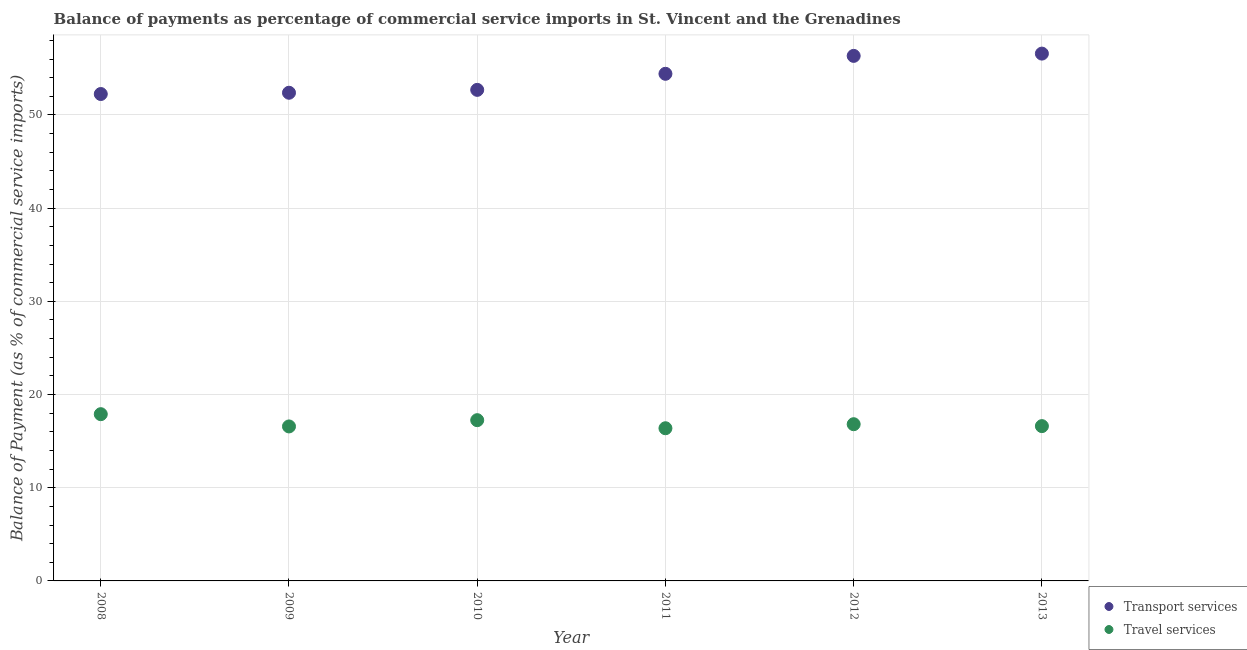Is the number of dotlines equal to the number of legend labels?
Your answer should be very brief. Yes. What is the balance of payments of transport services in 2008?
Offer a very short reply. 52.24. Across all years, what is the maximum balance of payments of travel services?
Your response must be concise. 17.89. Across all years, what is the minimum balance of payments of transport services?
Your answer should be very brief. 52.24. In which year was the balance of payments of transport services minimum?
Ensure brevity in your answer.  2008. What is the total balance of payments of transport services in the graph?
Your answer should be very brief. 324.64. What is the difference between the balance of payments of transport services in 2008 and that in 2009?
Provide a succinct answer. -0.14. What is the difference between the balance of payments of transport services in 2011 and the balance of payments of travel services in 2013?
Make the answer very short. 37.8. What is the average balance of payments of transport services per year?
Provide a short and direct response. 54.11. In the year 2011, what is the difference between the balance of payments of transport services and balance of payments of travel services?
Ensure brevity in your answer.  38.03. What is the ratio of the balance of payments of travel services in 2010 to that in 2012?
Offer a terse response. 1.03. What is the difference between the highest and the second highest balance of payments of travel services?
Your response must be concise. 0.64. What is the difference between the highest and the lowest balance of payments of travel services?
Your response must be concise. 1.51. Does the balance of payments of transport services monotonically increase over the years?
Make the answer very short. Yes. Is the balance of payments of transport services strictly greater than the balance of payments of travel services over the years?
Ensure brevity in your answer.  Yes. How many years are there in the graph?
Provide a succinct answer. 6. Are the values on the major ticks of Y-axis written in scientific E-notation?
Provide a succinct answer. No. How many legend labels are there?
Your answer should be very brief. 2. What is the title of the graph?
Your answer should be very brief. Balance of payments as percentage of commercial service imports in St. Vincent and the Grenadines. What is the label or title of the X-axis?
Keep it short and to the point. Year. What is the label or title of the Y-axis?
Offer a very short reply. Balance of Payment (as % of commercial service imports). What is the Balance of Payment (as % of commercial service imports) of Transport services in 2008?
Your response must be concise. 52.24. What is the Balance of Payment (as % of commercial service imports) in Travel services in 2008?
Ensure brevity in your answer.  17.89. What is the Balance of Payment (as % of commercial service imports) of Transport services in 2009?
Offer a terse response. 52.38. What is the Balance of Payment (as % of commercial service imports) in Travel services in 2009?
Your response must be concise. 16.58. What is the Balance of Payment (as % of commercial service imports) of Transport services in 2010?
Ensure brevity in your answer.  52.69. What is the Balance of Payment (as % of commercial service imports) in Travel services in 2010?
Keep it short and to the point. 17.25. What is the Balance of Payment (as % of commercial service imports) in Transport services in 2011?
Your answer should be very brief. 54.41. What is the Balance of Payment (as % of commercial service imports) in Travel services in 2011?
Make the answer very short. 16.38. What is the Balance of Payment (as % of commercial service imports) in Transport services in 2012?
Ensure brevity in your answer.  56.34. What is the Balance of Payment (as % of commercial service imports) of Travel services in 2012?
Offer a very short reply. 16.82. What is the Balance of Payment (as % of commercial service imports) of Transport services in 2013?
Offer a very short reply. 56.58. What is the Balance of Payment (as % of commercial service imports) in Travel services in 2013?
Provide a short and direct response. 16.61. Across all years, what is the maximum Balance of Payment (as % of commercial service imports) of Transport services?
Keep it short and to the point. 56.58. Across all years, what is the maximum Balance of Payment (as % of commercial service imports) of Travel services?
Make the answer very short. 17.89. Across all years, what is the minimum Balance of Payment (as % of commercial service imports) in Transport services?
Your answer should be compact. 52.24. Across all years, what is the minimum Balance of Payment (as % of commercial service imports) of Travel services?
Make the answer very short. 16.38. What is the total Balance of Payment (as % of commercial service imports) of Transport services in the graph?
Ensure brevity in your answer.  324.64. What is the total Balance of Payment (as % of commercial service imports) of Travel services in the graph?
Keep it short and to the point. 101.52. What is the difference between the Balance of Payment (as % of commercial service imports) in Transport services in 2008 and that in 2009?
Give a very brief answer. -0.14. What is the difference between the Balance of Payment (as % of commercial service imports) in Travel services in 2008 and that in 2009?
Keep it short and to the point. 1.32. What is the difference between the Balance of Payment (as % of commercial service imports) in Transport services in 2008 and that in 2010?
Offer a terse response. -0.45. What is the difference between the Balance of Payment (as % of commercial service imports) in Travel services in 2008 and that in 2010?
Your answer should be very brief. 0.64. What is the difference between the Balance of Payment (as % of commercial service imports) in Transport services in 2008 and that in 2011?
Your response must be concise. -2.17. What is the difference between the Balance of Payment (as % of commercial service imports) in Travel services in 2008 and that in 2011?
Give a very brief answer. 1.51. What is the difference between the Balance of Payment (as % of commercial service imports) in Transport services in 2008 and that in 2012?
Provide a short and direct response. -4.09. What is the difference between the Balance of Payment (as % of commercial service imports) in Travel services in 2008 and that in 2012?
Provide a succinct answer. 1.08. What is the difference between the Balance of Payment (as % of commercial service imports) of Transport services in 2008 and that in 2013?
Your answer should be compact. -4.34. What is the difference between the Balance of Payment (as % of commercial service imports) in Travel services in 2008 and that in 2013?
Offer a very short reply. 1.28. What is the difference between the Balance of Payment (as % of commercial service imports) of Transport services in 2009 and that in 2010?
Make the answer very short. -0.31. What is the difference between the Balance of Payment (as % of commercial service imports) of Travel services in 2009 and that in 2010?
Provide a succinct answer. -0.67. What is the difference between the Balance of Payment (as % of commercial service imports) in Transport services in 2009 and that in 2011?
Your answer should be very brief. -2.03. What is the difference between the Balance of Payment (as % of commercial service imports) of Travel services in 2009 and that in 2011?
Give a very brief answer. 0.19. What is the difference between the Balance of Payment (as % of commercial service imports) in Transport services in 2009 and that in 2012?
Keep it short and to the point. -3.96. What is the difference between the Balance of Payment (as % of commercial service imports) in Travel services in 2009 and that in 2012?
Offer a very short reply. -0.24. What is the difference between the Balance of Payment (as % of commercial service imports) of Transport services in 2009 and that in 2013?
Keep it short and to the point. -4.2. What is the difference between the Balance of Payment (as % of commercial service imports) of Travel services in 2009 and that in 2013?
Keep it short and to the point. -0.03. What is the difference between the Balance of Payment (as % of commercial service imports) in Transport services in 2010 and that in 2011?
Keep it short and to the point. -1.72. What is the difference between the Balance of Payment (as % of commercial service imports) in Travel services in 2010 and that in 2011?
Provide a short and direct response. 0.87. What is the difference between the Balance of Payment (as % of commercial service imports) in Transport services in 2010 and that in 2012?
Offer a very short reply. -3.65. What is the difference between the Balance of Payment (as % of commercial service imports) in Travel services in 2010 and that in 2012?
Your answer should be compact. 0.43. What is the difference between the Balance of Payment (as % of commercial service imports) in Transport services in 2010 and that in 2013?
Provide a succinct answer. -3.89. What is the difference between the Balance of Payment (as % of commercial service imports) in Travel services in 2010 and that in 2013?
Ensure brevity in your answer.  0.64. What is the difference between the Balance of Payment (as % of commercial service imports) in Transport services in 2011 and that in 2012?
Your answer should be compact. -1.92. What is the difference between the Balance of Payment (as % of commercial service imports) of Travel services in 2011 and that in 2012?
Your answer should be very brief. -0.43. What is the difference between the Balance of Payment (as % of commercial service imports) in Transport services in 2011 and that in 2013?
Give a very brief answer. -2.17. What is the difference between the Balance of Payment (as % of commercial service imports) of Travel services in 2011 and that in 2013?
Offer a terse response. -0.23. What is the difference between the Balance of Payment (as % of commercial service imports) in Transport services in 2012 and that in 2013?
Offer a very short reply. -0.24. What is the difference between the Balance of Payment (as % of commercial service imports) in Travel services in 2012 and that in 2013?
Ensure brevity in your answer.  0.2. What is the difference between the Balance of Payment (as % of commercial service imports) in Transport services in 2008 and the Balance of Payment (as % of commercial service imports) in Travel services in 2009?
Your response must be concise. 35.67. What is the difference between the Balance of Payment (as % of commercial service imports) in Transport services in 2008 and the Balance of Payment (as % of commercial service imports) in Travel services in 2010?
Your response must be concise. 35. What is the difference between the Balance of Payment (as % of commercial service imports) of Transport services in 2008 and the Balance of Payment (as % of commercial service imports) of Travel services in 2011?
Provide a succinct answer. 35.86. What is the difference between the Balance of Payment (as % of commercial service imports) in Transport services in 2008 and the Balance of Payment (as % of commercial service imports) in Travel services in 2012?
Your answer should be compact. 35.43. What is the difference between the Balance of Payment (as % of commercial service imports) of Transport services in 2008 and the Balance of Payment (as % of commercial service imports) of Travel services in 2013?
Your answer should be very brief. 35.63. What is the difference between the Balance of Payment (as % of commercial service imports) in Transport services in 2009 and the Balance of Payment (as % of commercial service imports) in Travel services in 2010?
Keep it short and to the point. 35.13. What is the difference between the Balance of Payment (as % of commercial service imports) in Transport services in 2009 and the Balance of Payment (as % of commercial service imports) in Travel services in 2011?
Offer a terse response. 36. What is the difference between the Balance of Payment (as % of commercial service imports) in Transport services in 2009 and the Balance of Payment (as % of commercial service imports) in Travel services in 2012?
Your answer should be compact. 35.56. What is the difference between the Balance of Payment (as % of commercial service imports) of Transport services in 2009 and the Balance of Payment (as % of commercial service imports) of Travel services in 2013?
Give a very brief answer. 35.77. What is the difference between the Balance of Payment (as % of commercial service imports) of Transport services in 2010 and the Balance of Payment (as % of commercial service imports) of Travel services in 2011?
Give a very brief answer. 36.31. What is the difference between the Balance of Payment (as % of commercial service imports) in Transport services in 2010 and the Balance of Payment (as % of commercial service imports) in Travel services in 2012?
Your answer should be very brief. 35.87. What is the difference between the Balance of Payment (as % of commercial service imports) in Transport services in 2010 and the Balance of Payment (as % of commercial service imports) in Travel services in 2013?
Ensure brevity in your answer.  36.08. What is the difference between the Balance of Payment (as % of commercial service imports) of Transport services in 2011 and the Balance of Payment (as % of commercial service imports) of Travel services in 2012?
Provide a succinct answer. 37.6. What is the difference between the Balance of Payment (as % of commercial service imports) in Transport services in 2011 and the Balance of Payment (as % of commercial service imports) in Travel services in 2013?
Make the answer very short. 37.8. What is the difference between the Balance of Payment (as % of commercial service imports) in Transport services in 2012 and the Balance of Payment (as % of commercial service imports) in Travel services in 2013?
Your answer should be compact. 39.72. What is the average Balance of Payment (as % of commercial service imports) in Transport services per year?
Provide a short and direct response. 54.11. What is the average Balance of Payment (as % of commercial service imports) in Travel services per year?
Your answer should be compact. 16.92. In the year 2008, what is the difference between the Balance of Payment (as % of commercial service imports) in Transport services and Balance of Payment (as % of commercial service imports) in Travel services?
Offer a very short reply. 34.35. In the year 2009, what is the difference between the Balance of Payment (as % of commercial service imports) in Transport services and Balance of Payment (as % of commercial service imports) in Travel services?
Make the answer very short. 35.8. In the year 2010, what is the difference between the Balance of Payment (as % of commercial service imports) in Transport services and Balance of Payment (as % of commercial service imports) in Travel services?
Provide a succinct answer. 35.44. In the year 2011, what is the difference between the Balance of Payment (as % of commercial service imports) of Transport services and Balance of Payment (as % of commercial service imports) of Travel services?
Provide a short and direct response. 38.03. In the year 2012, what is the difference between the Balance of Payment (as % of commercial service imports) in Transport services and Balance of Payment (as % of commercial service imports) in Travel services?
Provide a succinct answer. 39.52. In the year 2013, what is the difference between the Balance of Payment (as % of commercial service imports) in Transport services and Balance of Payment (as % of commercial service imports) in Travel services?
Ensure brevity in your answer.  39.97. What is the ratio of the Balance of Payment (as % of commercial service imports) in Travel services in 2008 to that in 2009?
Your answer should be compact. 1.08. What is the ratio of the Balance of Payment (as % of commercial service imports) in Transport services in 2008 to that in 2010?
Ensure brevity in your answer.  0.99. What is the ratio of the Balance of Payment (as % of commercial service imports) of Travel services in 2008 to that in 2010?
Provide a succinct answer. 1.04. What is the ratio of the Balance of Payment (as % of commercial service imports) in Transport services in 2008 to that in 2011?
Your answer should be very brief. 0.96. What is the ratio of the Balance of Payment (as % of commercial service imports) in Travel services in 2008 to that in 2011?
Your answer should be compact. 1.09. What is the ratio of the Balance of Payment (as % of commercial service imports) of Transport services in 2008 to that in 2012?
Your response must be concise. 0.93. What is the ratio of the Balance of Payment (as % of commercial service imports) in Travel services in 2008 to that in 2012?
Offer a terse response. 1.06. What is the ratio of the Balance of Payment (as % of commercial service imports) in Transport services in 2008 to that in 2013?
Offer a terse response. 0.92. What is the ratio of the Balance of Payment (as % of commercial service imports) in Travel services in 2008 to that in 2013?
Offer a very short reply. 1.08. What is the ratio of the Balance of Payment (as % of commercial service imports) of Transport services in 2009 to that in 2011?
Your response must be concise. 0.96. What is the ratio of the Balance of Payment (as % of commercial service imports) of Travel services in 2009 to that in 2011?
Provide a succinct answer. 1.01. What is the ratio of the Balance of Payment (as % of commercial service imports) of Transport services in 2009 to that in 2012?
Your answer should be compact. 0.93. What is the ratio of the Balance of Payment (as % of commercial service imports) of Travel services in 2009 to that in 2012?
Keep it short and to the point. 0.99. What is the ratio of the Balance of Payment (as % of commercial service imports) in Transport services in 2009 to that in 2013?
Provide a succinct answer. 0.93. What is the ratio of the Balance of Payment (as % of commercial service imports) of Transport services in 2010 to that in 2011?
Offer a terse response. 0.97. What is the ratio of the Balance of Payment (as % of commercial service imports) of Travel services in 2010 to that in 2011?
Provide a succinct answer. 1.05. What is the ratio of the Balance of Payment (as % of commercial service imports) of Transport services in 2010 to that in 2012?
Your response must be concise. 0.94. What is the ratio of the Balance of Payment (as % of commercial service imports) in Travel services in 2010 to that in 2012?
Your answer should be compact. 1.03. What is the ratio of the Balance of Payment (as % of commercial service imports) in Transport services in 2010 to that in 2013?
Your answer should be compact. 0.93. What is the ratio of the Balance of Payment (as % of commercial service imports) of Travel services in 2010 to that in 2013?
Your answer should be very brief. 1.04. What is the ratio of the Balance of Payment (as % of commercial service imports) of Transport services in 2011 to that in 2012?
Keep it short and to the point. 0.97. What is the ratio of the Balance of Payment (as % of commercial service imports) in Travel services in 2011 to that in 2012?
Offer a terse response. 0.97. What is the ratio of the Balance of Payment (as % of commercial service imports) of Transport services in 2011 to that in 2013?
Keep it short and to the point. 0.96. What is the ratio of the Balance of Payment (as % of commercial service imports) of Travel services in 2011 to that in 2013?
Your response must be concise. 0.99. What is the ratio of the Balance of Payment (as % of commercial service imports) of Transport services in 2012 to that in 2013?
Your answer should be compact. 1. What is the ratio of the Balance of Payment (as % of commercial service imports) of Travel services in 2012 to that in 2013?
Your response must be concise. 1.01. What is the difference between the highest and the second highest Balance of Payment (as % of commercial service imports) in Transport services?
Keep it short and to the point. 0.24. What is the difference between the highest and the second highest Balance of Payment (as % of commercial service imports) of Travel services?
Make the answer very short. 0.64. What is the difference between the highest and the lowest Balance of Payment (as % of commercial service imports) in Transport services?
Provide a short and direct response. 4.34. What is the difference between the highest and the lowest Balance of Payment (as % of commercial service imports) in Travel services?
Your response must be concise. 1.51. 